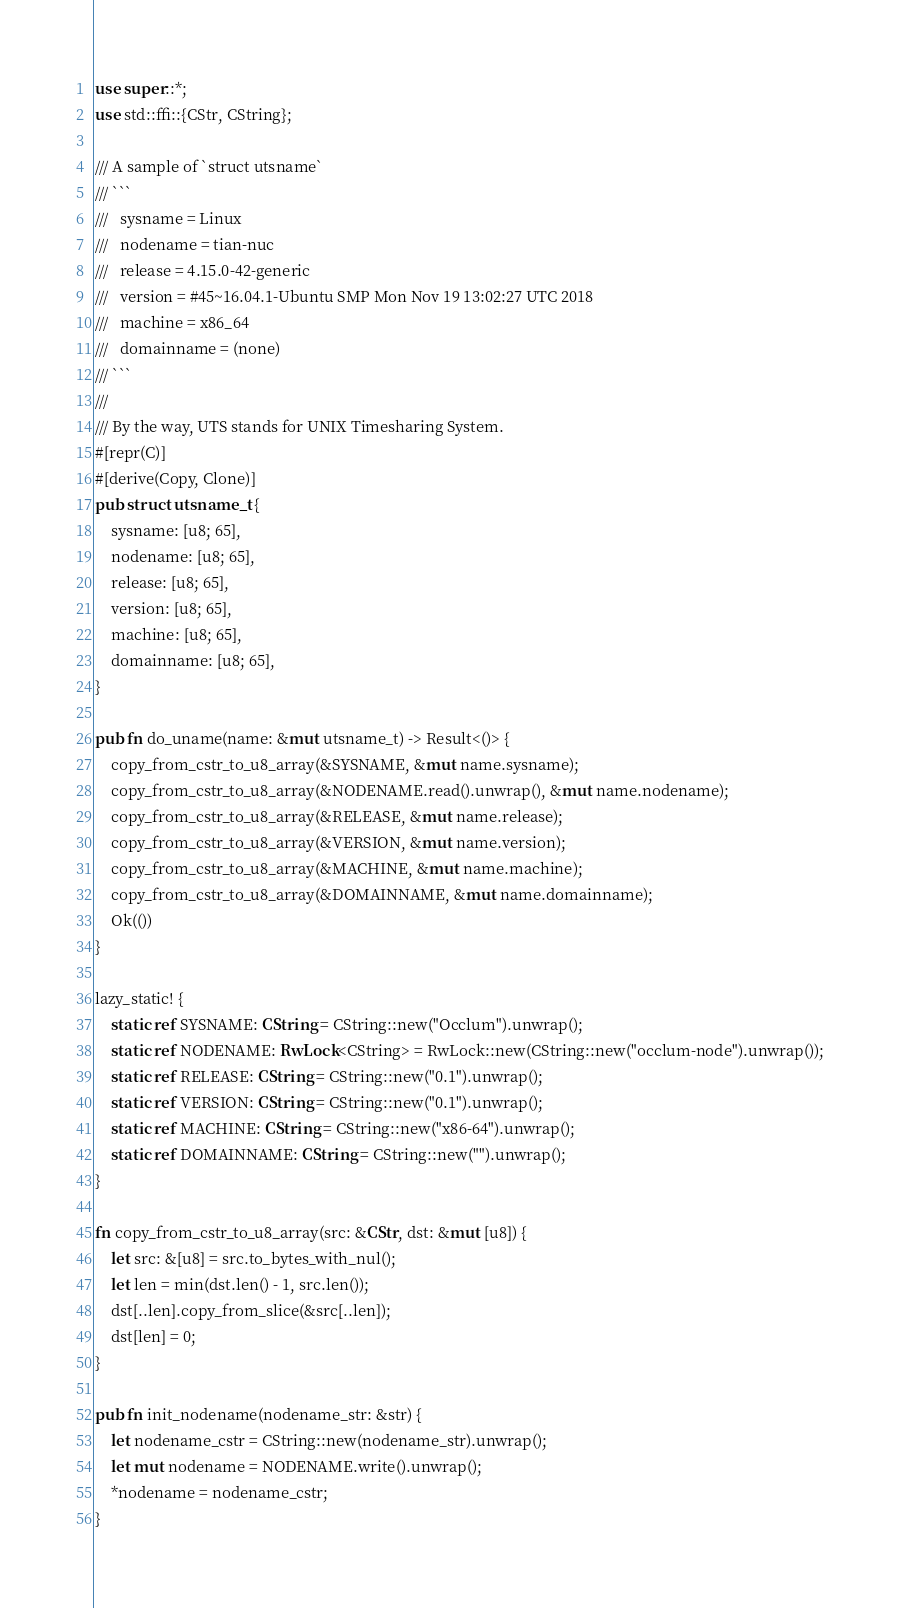Convert code to text. <code><loc_0><loc_0><loc_500><loc_500><_Rust_>use super::*;
use std::ffi::{CStr, CString};

/// A sample of `struct utsname`
/// ```
///   sysname = Linux
///   nodename = tian-nuc
///   release = 4.15.0-42-generic
///   version = #45~16.04.1-Ubuntu SMP Mon Nov 19 13:02:27 UTC 2018
///   machine = x86_64
///   domainname = (none)
/// ```
///
/// By the way, UTS stands for UNIX Timesharing System.
#[repr(C)]
#[derive(Copy, Clone)]
pub struct utsname_t {
    sysname: [u8; 65],
    nodename: [u8; 65],
    release: [u8; 65],
    version: [u8; 65],
    machine: [u8; 65],
    domainname: [u8; 65],
}

pub fn do_uname(name: &mut utsname_t) -> Result<()> {
    copy_from_cstr_to_u8_array(&SYSNAME, &mut name.sysname);
    copy_from_cstr_to_u8_array(&NODENAME.read().unwrap(), &mut name.nodename);
    copy_from_cstr_to_u8_array(&RELEASE, &mut name.release);
    copy_from_cstr_to_u8_array(&VERSION, &mut name.version);
    copy_from_cstr_to_u8_array(&MACHINE, &mut name.machine);
    copy_from_cstr_to_u8_array(&DOMAINNAME, &mut name.domainname);
    Ok(())
}

lazy_static! {
    static ref SYSNAME: CString = CString::new("Occlum").unwrap();
    static ref NODENAME: RwLock<CString> = RwLock::new(CString::new("occlum-node").unwrap());
    static ref RELEASE: CString = CString::new("0.1").unwrap();
    static ref VERSION: CString = CString::new("0.1").unwrap();
    static ref MACHINE: CString = CString::new("x86-64").unwrap();
    static ref DOMAINNAME: CString = CString::new("").unwrap();
}

fn copy_from_cstr_to_u8_array(src: &CStr, dst: &mut [u8]) {
    let src: &[u8] = src.to_bytes_with_nul();
    let len = min(dst.len() - 1, src.len());
    dst[..len].copy_from_slice(&src[..len]);
    dst[len] = 0;
}

pub fn init_nodename(nodename_str: &str) {
    let nodename_cstr = CString::new(nodename_str).unwrap();
    let mut nodename = NODENAME.write().unwrap();
    *nodename = nodename_cstr;
}
</code> 